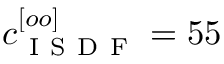Convert formula to latex. <formula><loc_0><loc_0><loc_500><loc_500>c _ { I S D F } ^ { [ o o ] } = 5 5</formula> 